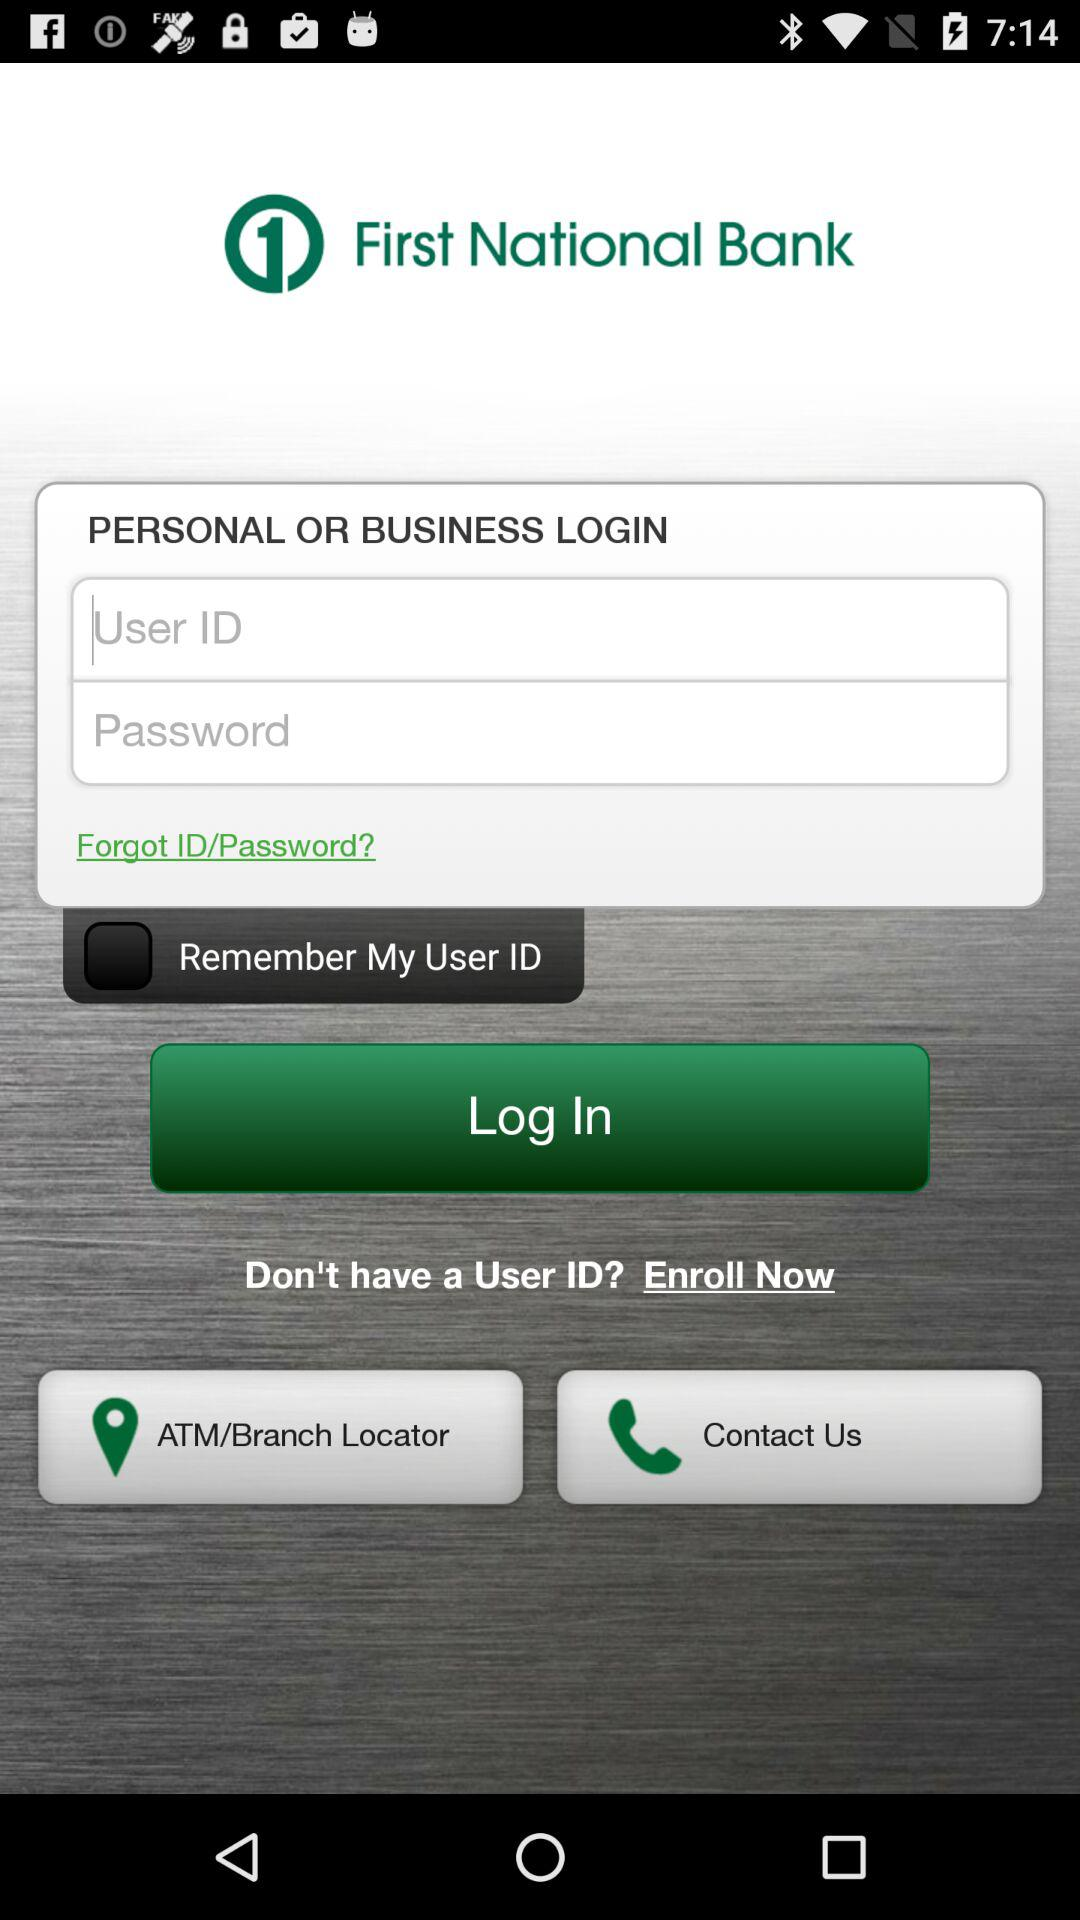What is the status of "Remember My User ID"? The status is "off". 